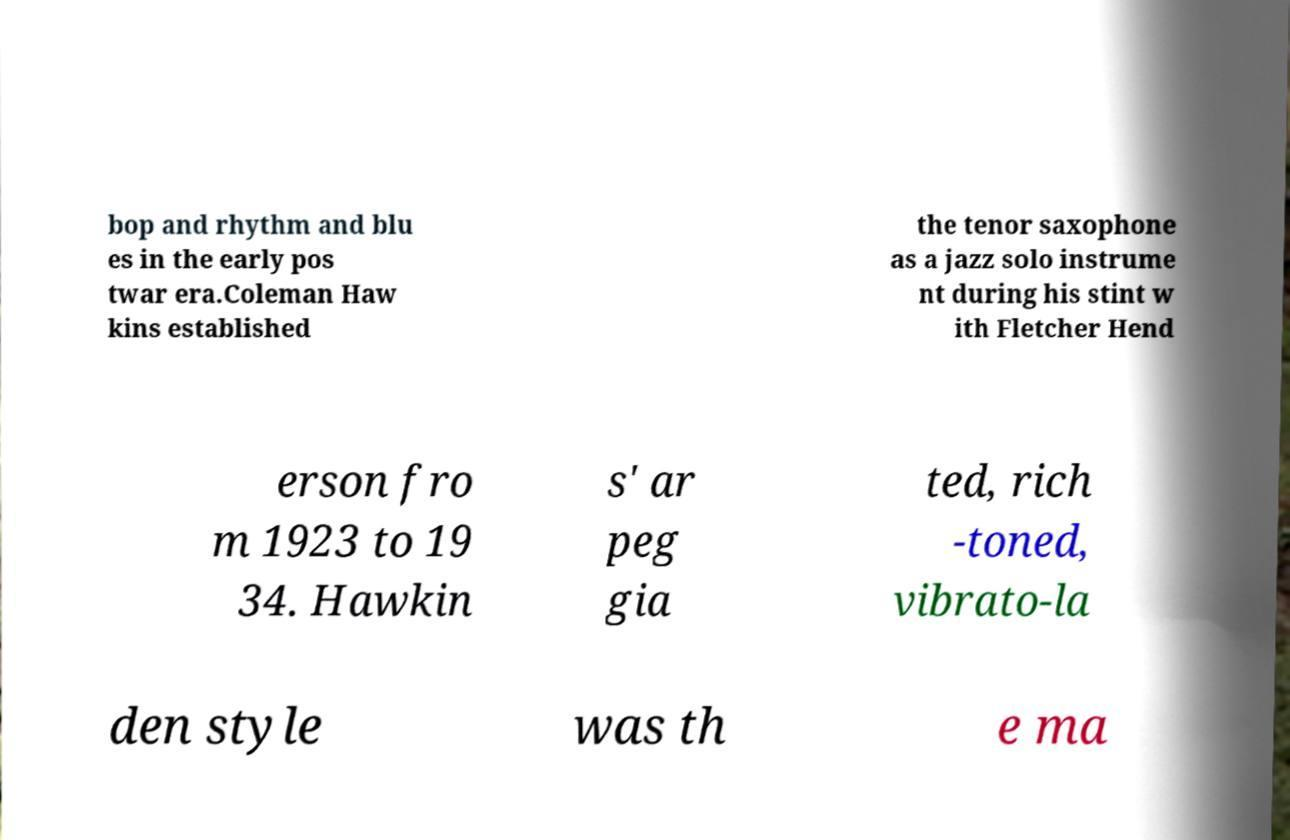Could you assist in decoding the text presented in this image and type it out clearly? bop and rhythm and blu es in the early pos twar era.Coleman Haw kins established the tenor saxophone as a jazz solo instrume nt during his stint w ith Fletcher Hend erson fro m 1923 to 19 34. Hawkin s' ar peg gia ted, rich -toned, vibrato-la den style was th e ma 